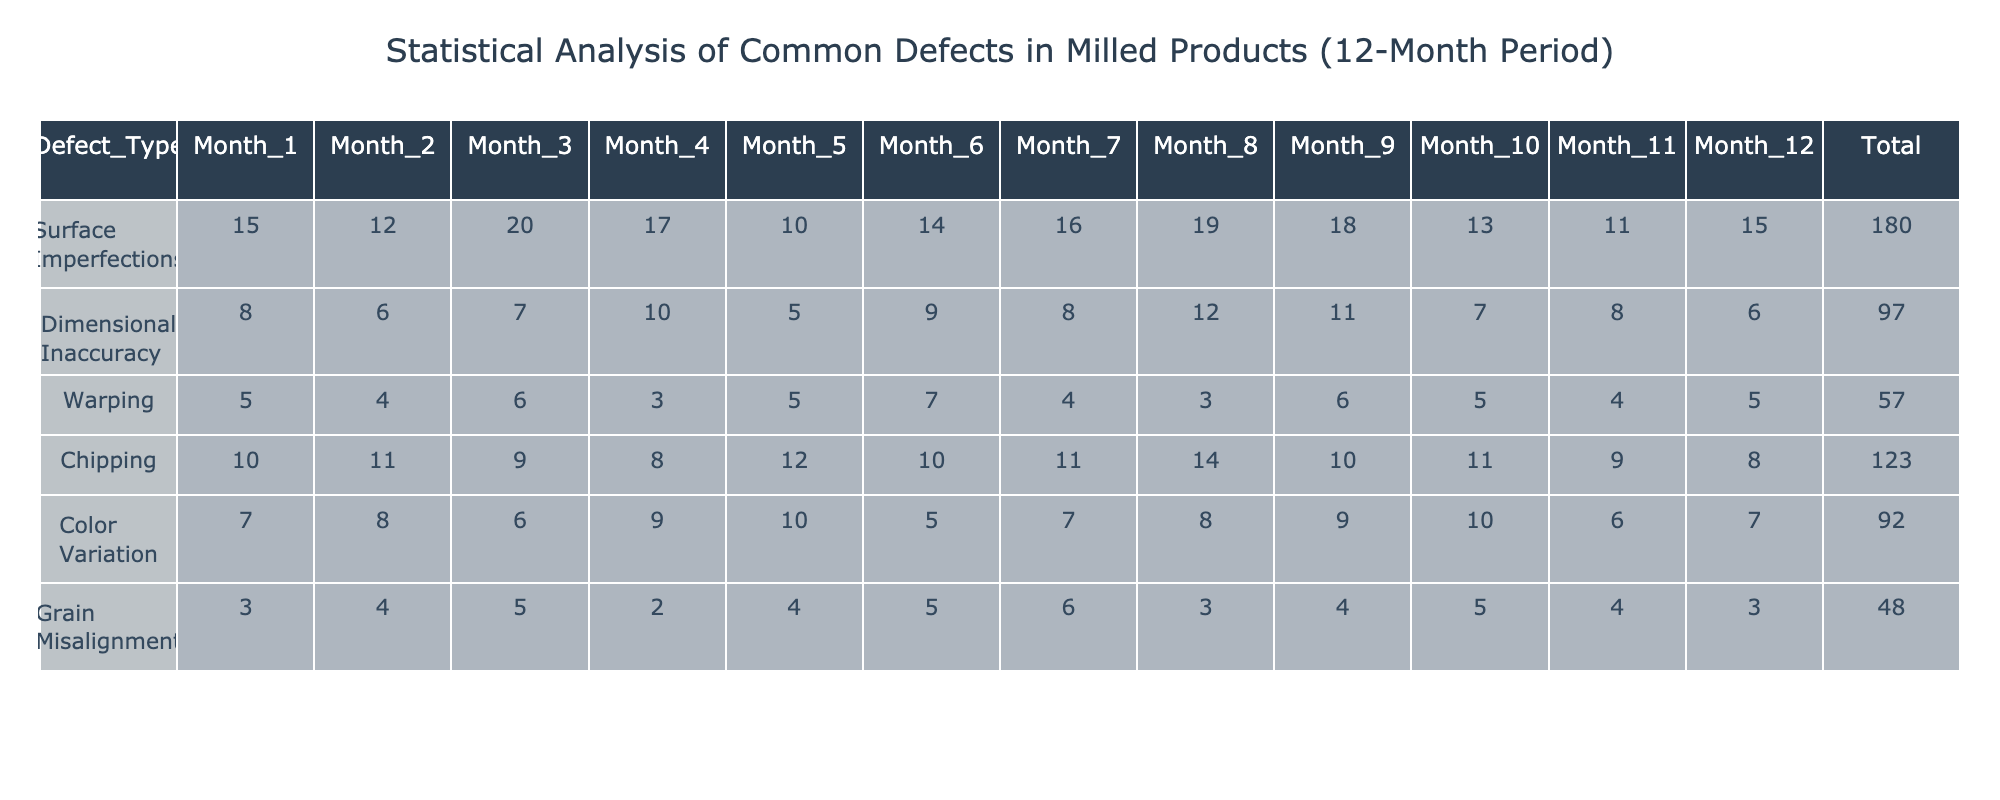What is the total number of surface imperfections reported over the 12 months? To find the total number of surface imperfections, we need to sum all the values in the "Surface Imperfections" row: 15 + 12 + 20 + 17 + 10 + 14 + 16 + 19 + 18 + 13 + 11 + 15 =  15 + 12 + 20 + 17 + 10 + 14 + 16 + 19 + 18 + 13 + 11 + 15 =  15 + 12 = 27  + 20 = 47 + 17 = 64 + 10 = 74 + 14 = 88 + 16 = 104 + 19 = 123 + 18 = 141 + 13 = 154 + 11 = 165 + 15 = 180.
Answer: 180 Which defect type had the highest monthly occurrence in Month 5? In Month 5, we compare values of all defect types: Surface Imperfections = 10, Dimensional Inaccuracy = 5, Warping = 5, Chipping = 12, Color Variation = 10, and Grain Misalignment = 4. The highest value here is for Chipping at 12.
Answer: Chipping What is the average number of chipping defects over the 12 months? To calculate the average, first sum the values for Chipping: 10 + 11 + 9 + 8 + 12 + 10 + 11 + 14 + 10 + 11 + 9 + 8 = 10 + 11 = 21 + 9 = 30 + 8 = 38 + 12 = 50 + 10 = 60 + 11 = 71 + 14 = 85 + 10 = 95 + 11 = 106 + 9 = 115 + 8 = 123, which equals 123. Next, divide by the number of months (12): 123 / 12 = 10.25.
Answer: 10.25 Is there a trend in surface imperfections over the 12 months? Looking at the data, we observe the values: 15, 12, 20, 17, 10, 14, 16, 19, 18, 13, 11, 15. The trend initially increased, peaked at 20 in Month 3, then fluctuated but returned to 15 in Month 12. The overall trend does not indicate consistent growth or decline.
Answer: No consistent trend What is the difference in total defects between Month 1 and Month 12? First, calculate the total defects for each month by summing the values in each respective month. For Month 1: 15 + 8 + 5 + 10 + 7 + 3 = 48. For Month 12: 15 + 6 + 5 + 8 + 7 + 3 = 44. The difference is 48 - 44 = 4.
Answer: 4 